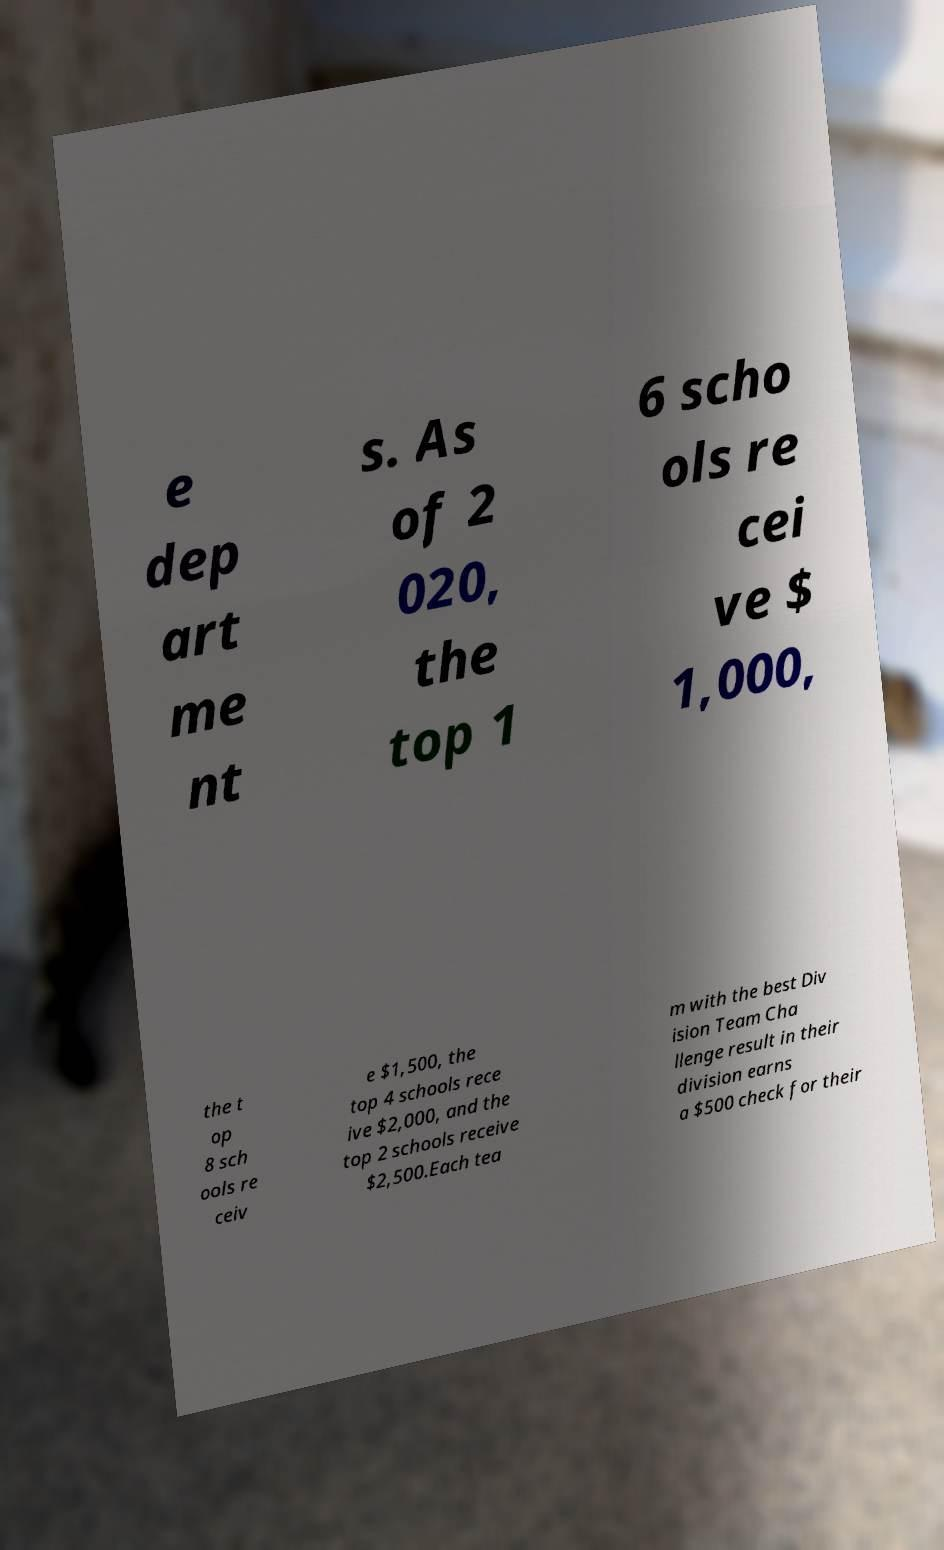For documentation purposes, I need the text within this image transcribed. Could you provide that? e dep art me nt s. As of 2 020, the top 1 6 scho ols re cei ve $ 1,000, the t op 8 sch ools re ceiv e $1,500, the top 4 schools rece ive $2,000, and the top 2 schools receive $2,500.Each tea m with the best Div ision Team Cha llenge result in their division earns a $500 check for their 